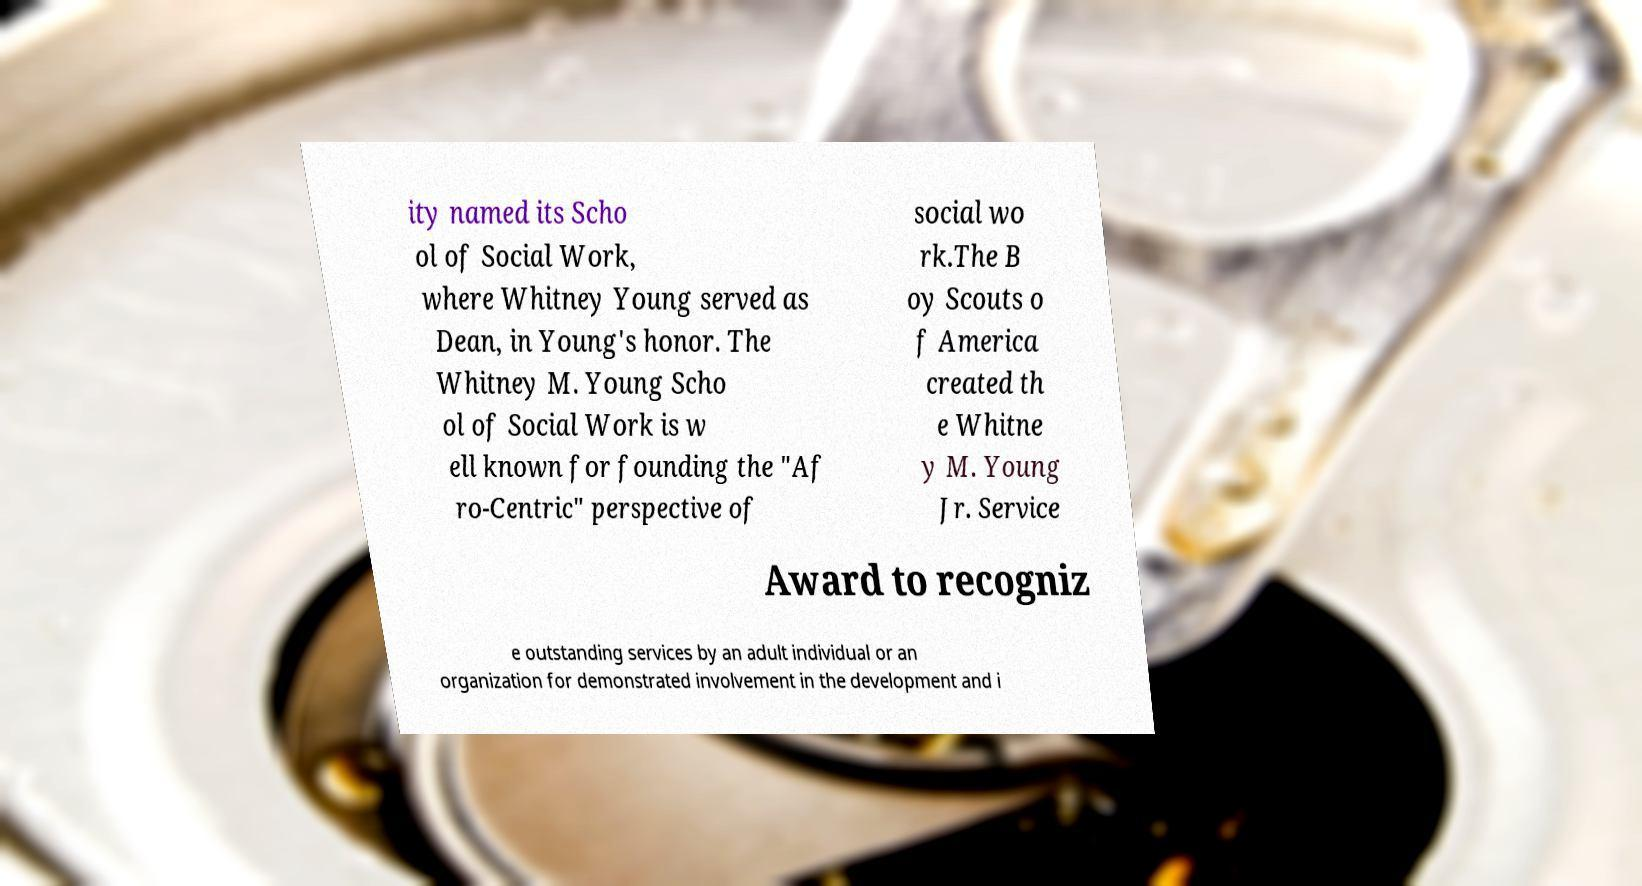What messages or text are displayed in this image? I need them in a readable, typed format. ity named its Scho ol of Social Work, where Whitney Young served as Dean, in Young's honor. The Whitney M. Young Scho ol of Social Work is w ell known for founding the "Af ro-Centric" perspective of social wo rk.The B oy Scouts o f America created th e Whitne y M. Young Jr. Service Award to recogniz e outstanding services by an adult individual or an organization for demonstrated involvement in the development and i 